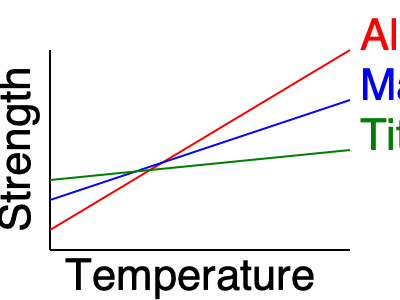Based on the graph showing the relationship between temperature and strength for various lightweight alloys, which alloy maintains the highest strength at elevated temperatures? To determine which alloy maintains the highest strength at elevated temperatures, we need to analyze the graph:

1. The graph shows the relationship between temperature (x-axis) and strength (y-axis) for three lightweight alloys: Aluminum (red), Magnesium (blue), and Titanium (green).

2. As temperature increases (moving right on the x-axis), the strength of all alloys decreases (moving down on the y-axis).

3. At lower temperatures (left side of the graph), Aluminum has the highest strength, followed by Magnesium, then Titanium.

4. However, as temperature increases:
   - Aluminum's strength decreases rapidly (steepest slope)
   - Magnesium's strength decreases less rapidly
   - Titanium's strength decreases the least (shallowest slope)

5. At the highest temperatures (right side of the graph), Titanium has the highest strength, followed by Magnesium, then Aluminum.

6. Since we're interested in strength at elevated temperatures, we focus on the right side of the graph.

Therefore, Titanium maintains the highest strength at elevated temperatures among the three alloys shown.
Answer: Titanium 